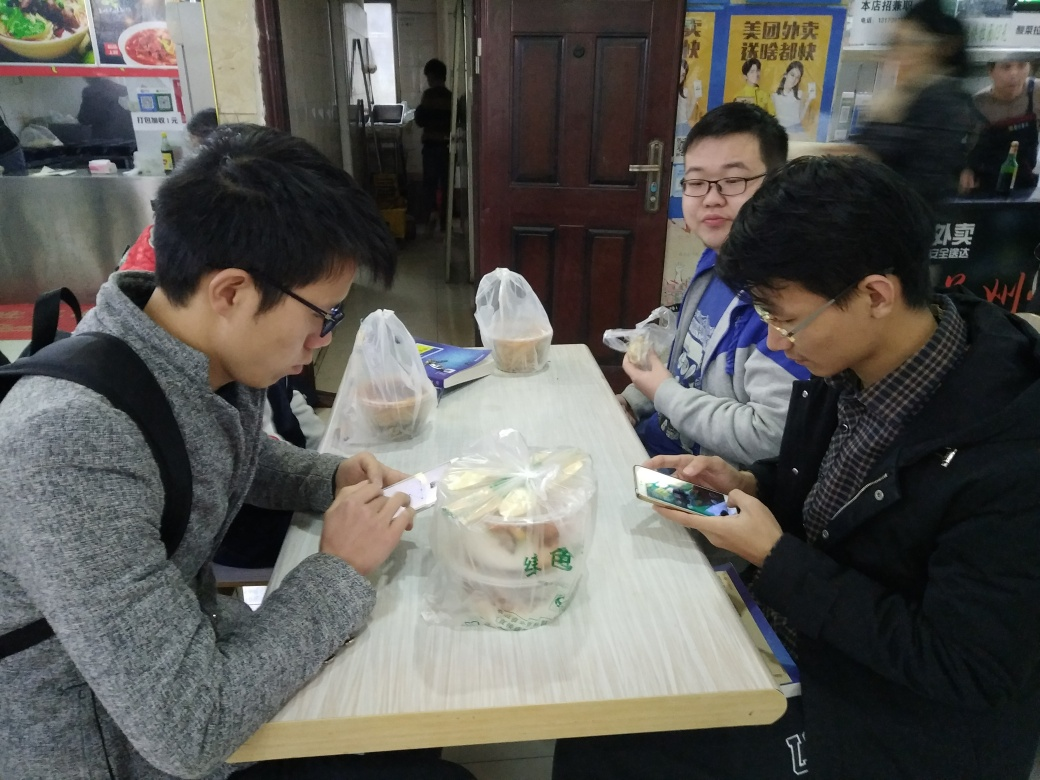Are the outlines of the main characters in the image clear?
A. No
B. Yes
Answer with the option's letter from the given choices directly.
 B. 